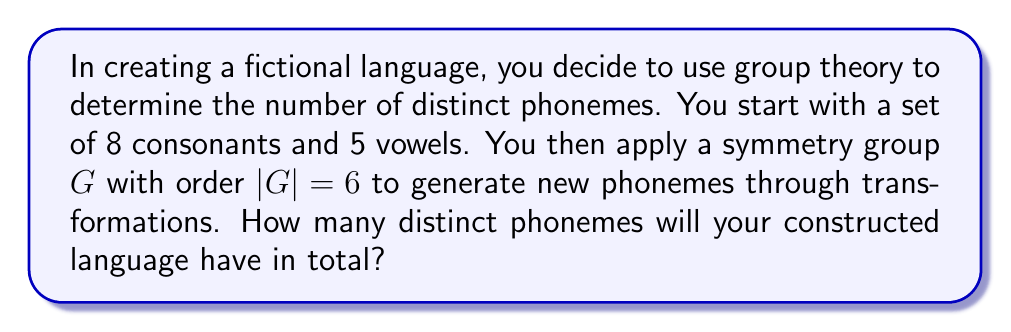Show me your answer to this math problem. Let's approach this step-by-step using concepts from group theory:

1) We start with a base set of phonemes:
   - 8 consonants
   - 5 vowels
   Total initial phonemes: $8 + 5 = 13$

2) We apply a symmetry group $G$ with order $|G| = 6$. This means there are 6 distinct transformations (including the identity transformation) that can be applied to our phonemes.

3) In group theory, when we apply a group to a set, we generate orbits. Each orbit represents a set of elements that can be transformed into each other by the group actions.

4) The Orbit-Stabilizer theorem states that the size of each orbit divides the order of the group. In this case, possible orbit sizes are factors of 6: 1, 2, 3, or 6.

5) To maximize the number of distinct phonemes, we want to have as many orbits of size 1 as possible, as these represent phonemes that remain unchanged under all transformations.

6) The remaining phonemes will form orbits of size 6 (the full orbit size), as this gives us the maximum number of new, distinct phonemes.

7) Let $x$ be the number of orbits of size 1, and $y$ be the number of orbits of size 6.
   Then: $x + 6y = 13$ (our initial number of phonemes)

8) Solving this equation with non-negative integers, we get $x = 1$ and $y = 2$

9) Therefore, we have:
   - 1 phoneme unchanged (orbit of size 1)
   - 2 orbits of size 6, each generating 5 new phonemes (12 new phonemes in total)

10) The total number of distinct phonemes is thus:
    $13$ (initial) $+ 12$ (new) $= 25$
Answer: 25 distinct phonemes 